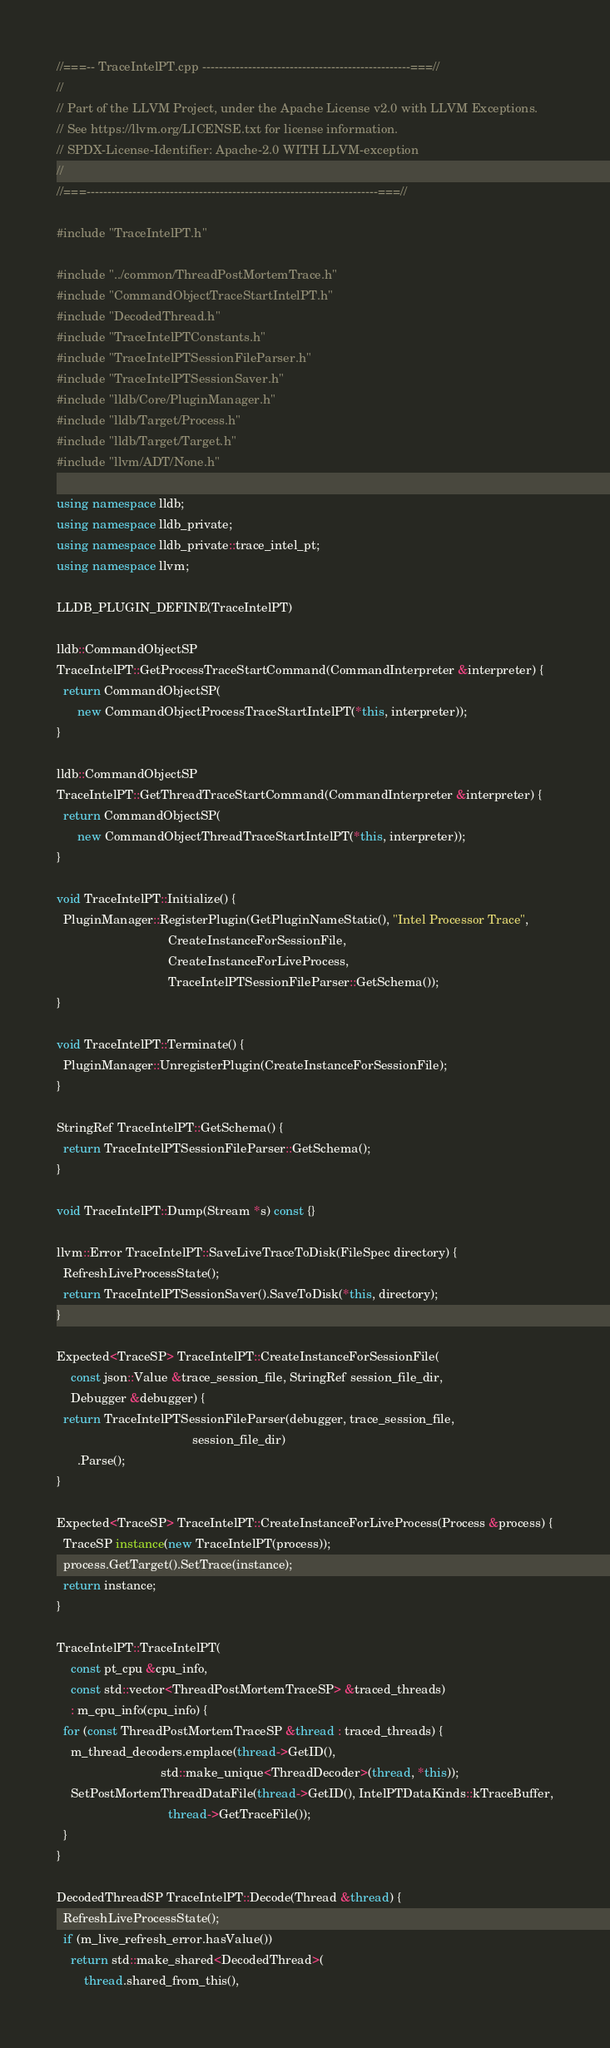Convert code to text. <code><loc_0><loc_0><loc_500><loc_500><_C++_>//===-- TraceIntelPT.cpp --------------------------------------------------===//
//
// Part of the LLVM Project, under the Apache License v2.0 with LLVM Exceptions.
// See https://llvm.org/LICENSE.txt for license information.
// SPDX-License-Identifier: Apache-2.0 WITH LLVM-exception
//
//===----------------------------------------------------------------------===//

#include "TraceIntelPT.h"

#include "../common/ThreadPostMortemTrace.h"
#include "CommandObjectTraceStartIntelPT.h"
#include "DecodedThread.h"
#include "TraceIntelPTConstants.h"
#include "TraceIntelPTSessionFileParser.h"
#include "TraceIntelPTSessionSaver.h"
#include "lldb/Core/PluginManager.h"
#include "lldb/Target/Process.h"
#include "lldb/Target/Target.h"
#include "llvm/ADT/None.h"

using namespace lldb;
using namespace lldb_private;
using namespace lldb_private::trace_intel_pt;
using namespace llvm;

LLDB_PLUGIN_DEFINE(TraceIntelPT)

lldb::CommandObjectSP
TraceIntelPT::GetProcessTraceStartCommand(CommandInterpreter &interpreter) {
  return CommandObjectSP(
      new CommandObjectProcessTraceStartIntelPT(*this, interpreter));
}

lldb::CommandObjectSP
TraceIntelPT::GetThreadTraceStartCommand(CommandInterpreter &interpreter) {
  return CommandObjectSP(
      new CommandObjectThreadTraceStartIntelPT(*this, interpreter));
}

void TraceIntelPT::Initialize() {
  PluginManager::RegisterPlugin(GetPluginNameStatic(), "Intel Processor Trace",
                                CreateInstanceForSessionFile,
                                CreateInstanceForLiveProcess,
                                TraceIntelPTSessionFileParser::GetSchema());
}

void TraceIntelPT::Terminate() {
  PluginManager::UnregisterPlugin(CreateInstanceForSessionFile);
}

StringRef TraceIntelPT::GetSchema() {
  return TraceIntelPTSessionFileParser::GetSchema();
}

void TraceIntelPT::Dump(Stream *s) const {}

llvm::Error TraceIntelPT::SaveLiveTraceToDisk(FileSpec directory) {
  RefreshLiveProcessState();
  return TraceIntelPTSessionSaver().SaveToDisk(*this, directory);
}

Expected<TraceSP> TraceIntelPT::CreateInstanceForSessionFile(
    const json::Value &trace_session_file, StringRef session_file_dir,
    Debugger &debugger) {
  return TraceIntelPTSessionFileParser(debugger, trace_session_file,
                                       session_file_dir)
      .Parse();
}

Expected<TraceSP> TraceIntelPT::CreateInstanceForLiveProcess(Process &process) {
  TraceSP instance(new TraceIntelPT(process));
  process.GetTarget().SetTrace(instance);
  return instance;
}

TraceIntelPT::TraceIntelPT(
    const pt_cpu &cpu_info,
    const std::vector<ThreadPostMortemTraceSP> &traced_threads)
    : m_cpu_info(cpu_info) {
  for (const ThreadPostMortemTraceSP &thread : traced_threads) {
    m_thread_decoders.emplace(thread->GetID(),
                              std::make_unique<ThreadDecoder>(thread, *this));
    SetPostMortemThreadDataFile(thread->GetID(), IntelPTDataKinds::kTraceBuffer,
                                thread->GetTraceFile());
  }
}

DecodedThreadSP TraceIntelPT::Decode(Thread &thread) {
  RefreshLiveProcessState();
  if (m_live_refresh_error.hasValue())
    return std::make_shared<DecodedThread>(
        thread.shared_from_this(),</code> 